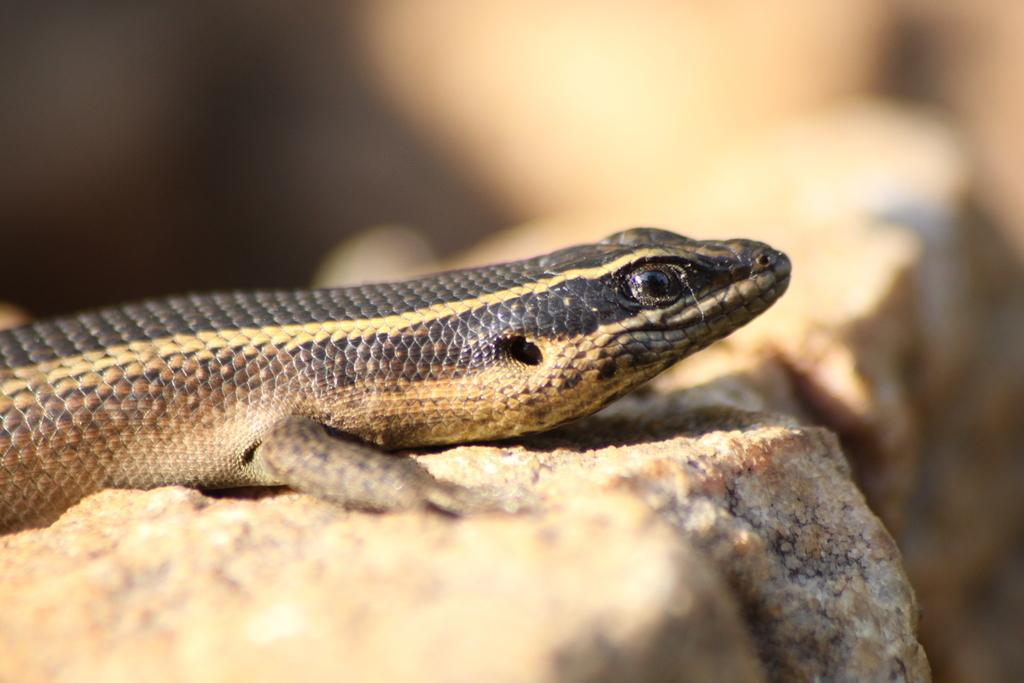Where was the image taken? The image was clicked outside. What is the main subject of the image? There is a reptile in the center of the image. What is the reptile resting on? The reptile is on an object. Can you describe the background of the image? The background of the image is blurry. What type of curtain can be seen in the image? There is no curtain present in the image. Is the reptile lying on a sheet in the image? The image does not show a sheet, and the reptile is resting on an object, not a sheet. 